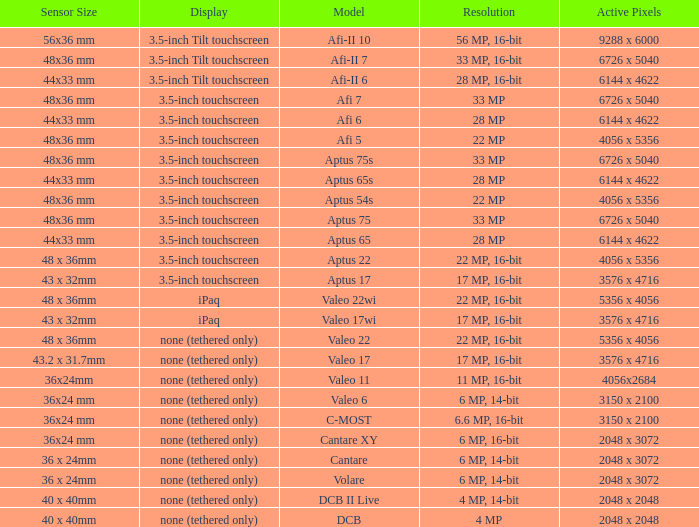What is the image clarity of the camera with 6726 x 5040 pixels and an afi 7 model? 33 MP. 